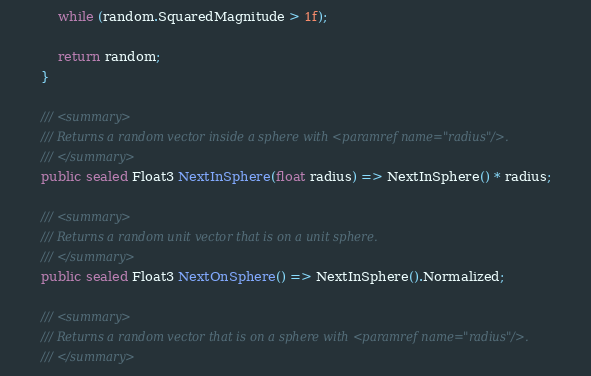<code> <loc_0><loc_0><loc_500><loc_500><_C#_>			while (random.SquaredMagnitude > 1f);

			return random;
		}

		/// <summary>
		/// Returns a random vector inside a sphere with <paramref name="radius"/>.
		/// </summary>
		public sealed Float3 NextInSphere(float radius) => NextInSphere() * radius;

		/// <summary>
		/// Returns a random unit vector that is on a unit sphere.
		/// </summary>
		public sealed Float3 NextOnSphere() => NextInSphere().Normalized;

		/// <summary>
		/// Returns a random vector that is on a sphere with <paramref name="radius"/>.
		/// </summary></code> 